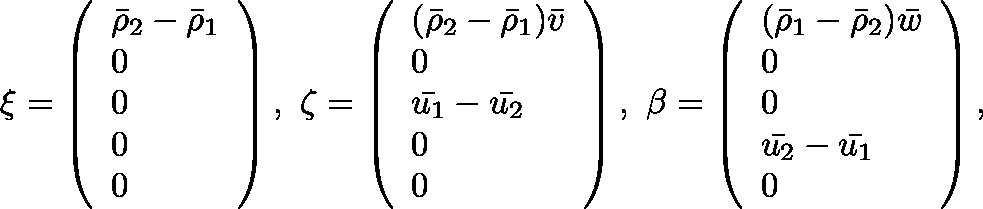<formula> <loc_0><loc_0><loc_500><loc_500>\xi = \left ( \begin{array} { l } { \bar { \rho } _ { 2 } - \bar { \rho } _ { 1 } } \\ { 0 } \\ { 0 } \\ { 0 } \\ { 0 } \end{array} \right ) , \ \zeta = \left ( \begin{array} { l } { ( \bar { \rho } _ { 2 } - \bar { \rho } _ { 1 } ) \bar { v } } \\ { 0 } \\ { \bar { u _ { 1 } } - \bar { u _ { 2 } } } \\ { 0 } \\ { 0 } \end{array} \right ) , \ \beta = \left ( \begin{array} { l } { ( \bar { \rho } _ { 1 } - \bar { \rho } _ { 2 } ) \bar { w } } \\ { 0 } \\ { 0 } \\ { \bar { u _ { 2 } } - \bar { u _ { 1 } } } \\ { 0 } \end{array} \right ) ,</formula> 